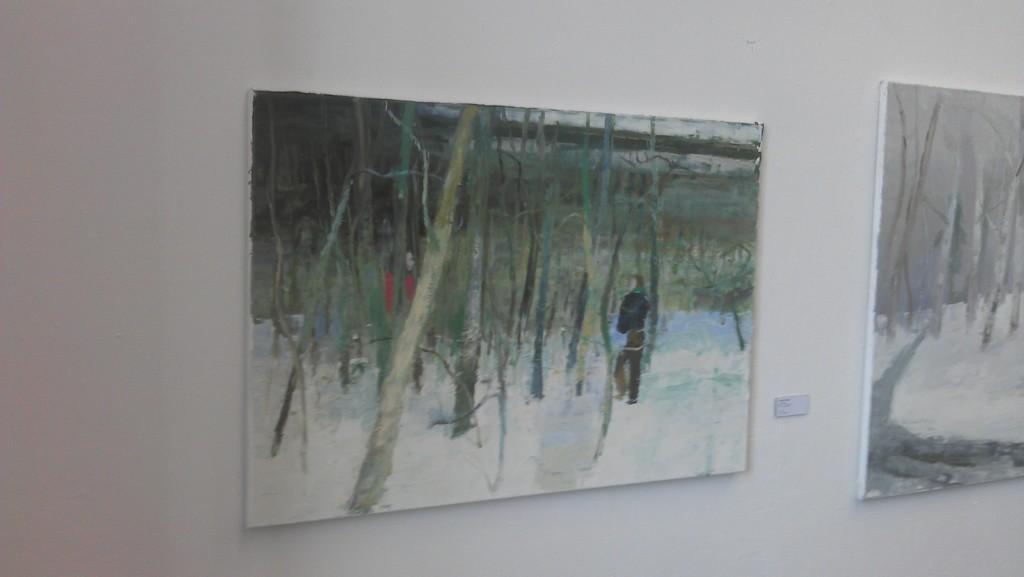Can you describe this image briefly? In this image we can see two photo frames and an object on the wall. 